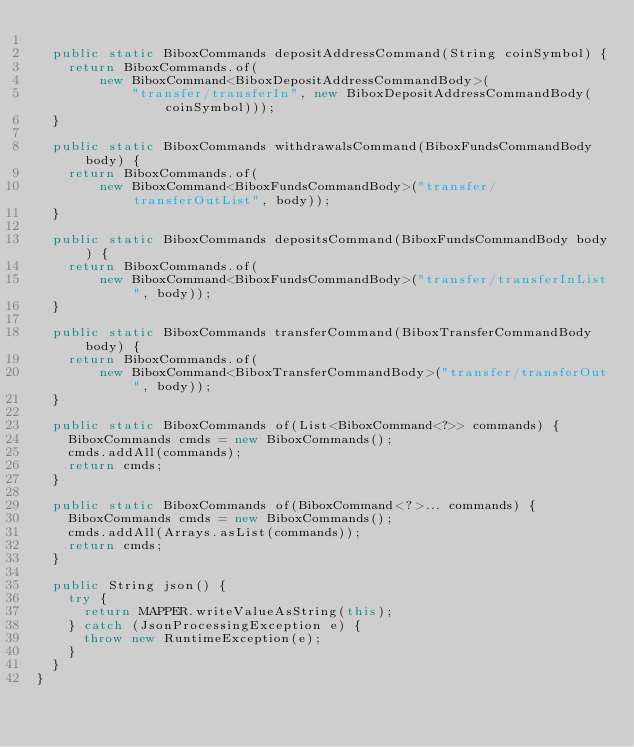Convert code to text. <code><loc_0><loc_0><loc_500><loc_500><_Java_>
  public static BiboxCommands depositAddressCommand(String coinSymbol) {
    return BiboxCommands.of(
        new BiboxCommand<BiboxDepositAddressCommandBody>(
            "transfer/transferIn", new BiboxDepositAddressCommandBody(coinSymbol)));
  }

  public static BiboxCommands withdrawalsCommand(BiboxFundsCommandBody body) {
    return BiboxCommands.of(
        new BiboxCommand<BiboxFundsCommandBody>("transfer/transferOutList", body));
  }

  public static BiboxCommands depositsCommand(BiboxFundsCommandBody body) {
    return BiboxCommands.of(
        new BiboxCommand<BiboxFundsCommandBody>("transfer/transferInList", body));
  }

  public static BiboxCommands transferCommand(BiboxTransferCommandBody body) {
    return BiboxCommands.of(
        new BiboxCommand<BiboxTransferCommandBody>("transfer/transferOut", body));
  }

  public static BiboxCommands of(List<BiboxCommand<?>> commands) {
    BiboxCommands cmds = new BiboxCommands();
    cmds.addAll(commands);
    return cmds;
  }

  public static BiboxCommands of(BiboxCommand<?>... commands) {
    BiboxCommands cmds = new BiboxCommands();
    cmds.addAll(Arrays.asList(commands));
    return cmds;
  }

  public String json() {
    try {
      return MAPPER.writeValueAsString(this);
    } catch (JsonProcessingException e) {
      throw new RuntimeException(e);
    }
  }
}
</code> 